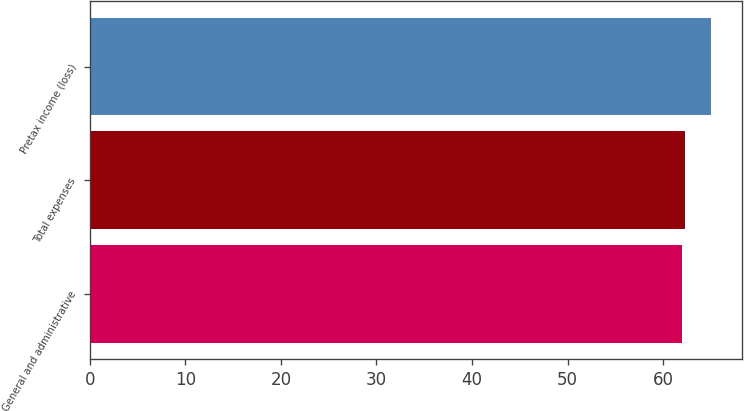<chart> <loc_0><loc_0><loc_500><loc_500><bar_chart><fcel>General and administrative<fcel>Total expenses<fcel>Pretax income (loss)<nl><fcel>62<fcel>62.3<fcel>65<nl></chart> 